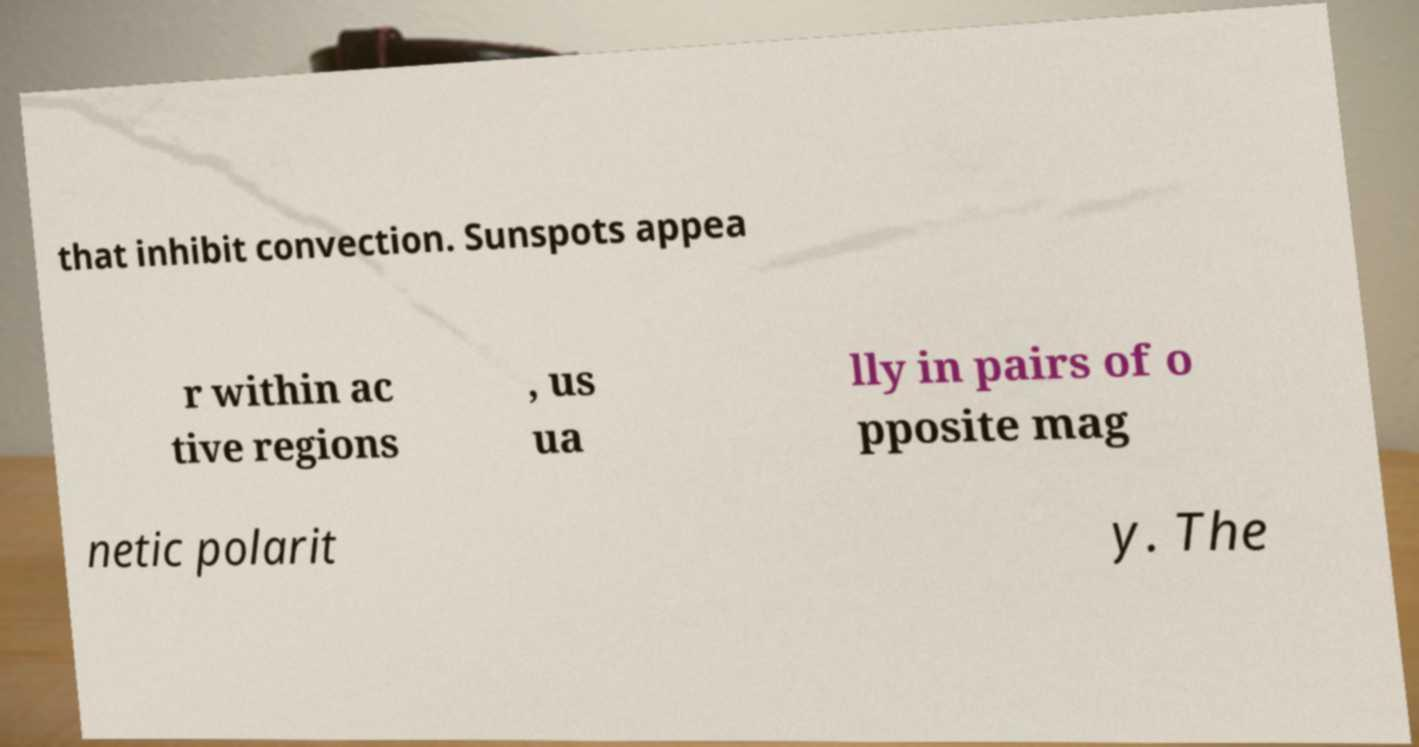I need the written content from this picture converted into text. Can you do that? that inhibit convection. Sunspots appea r within ac tive regions , us ua lly in pairs of o pposite mag netic polarit y. The 